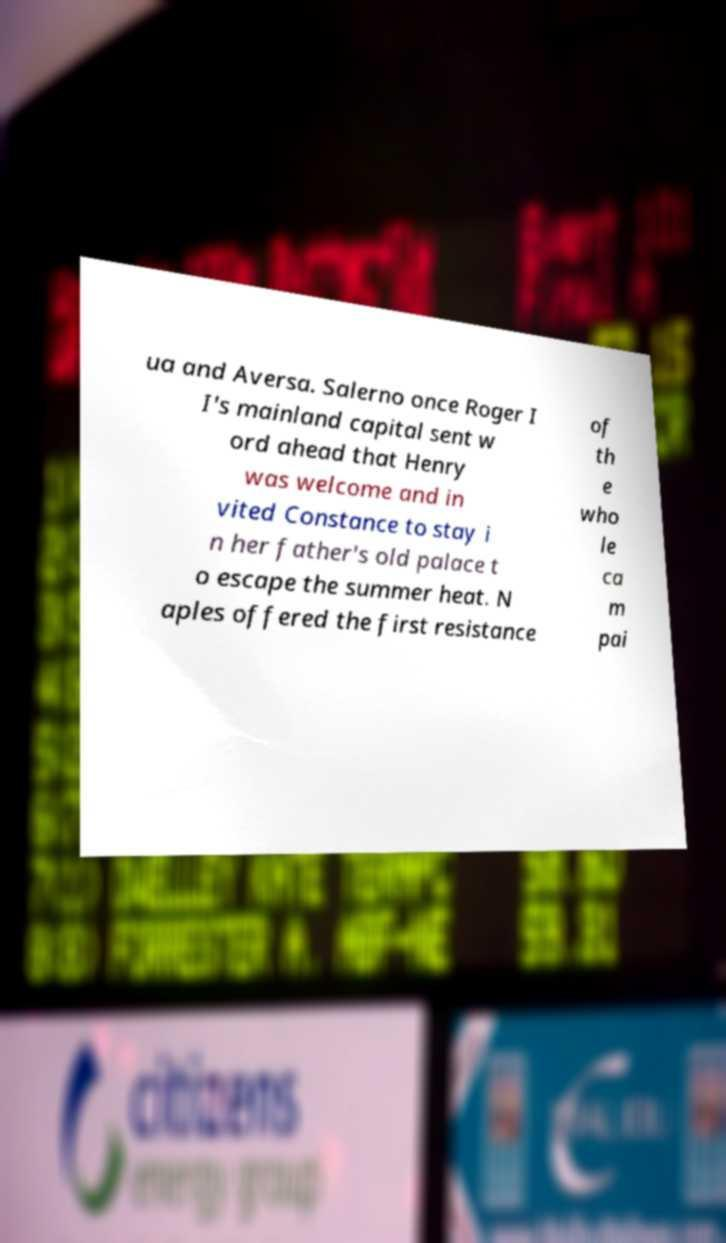Could you extract and type out the text from this image? ua and Aversa. Salerno once Roger I I's mainland capital sent w ord ahead that Henry was welcome and in vited Constance to stay i n her father's old palace t o escape the summer heat. N aples offered the first resistance of th e who le ca m pai 